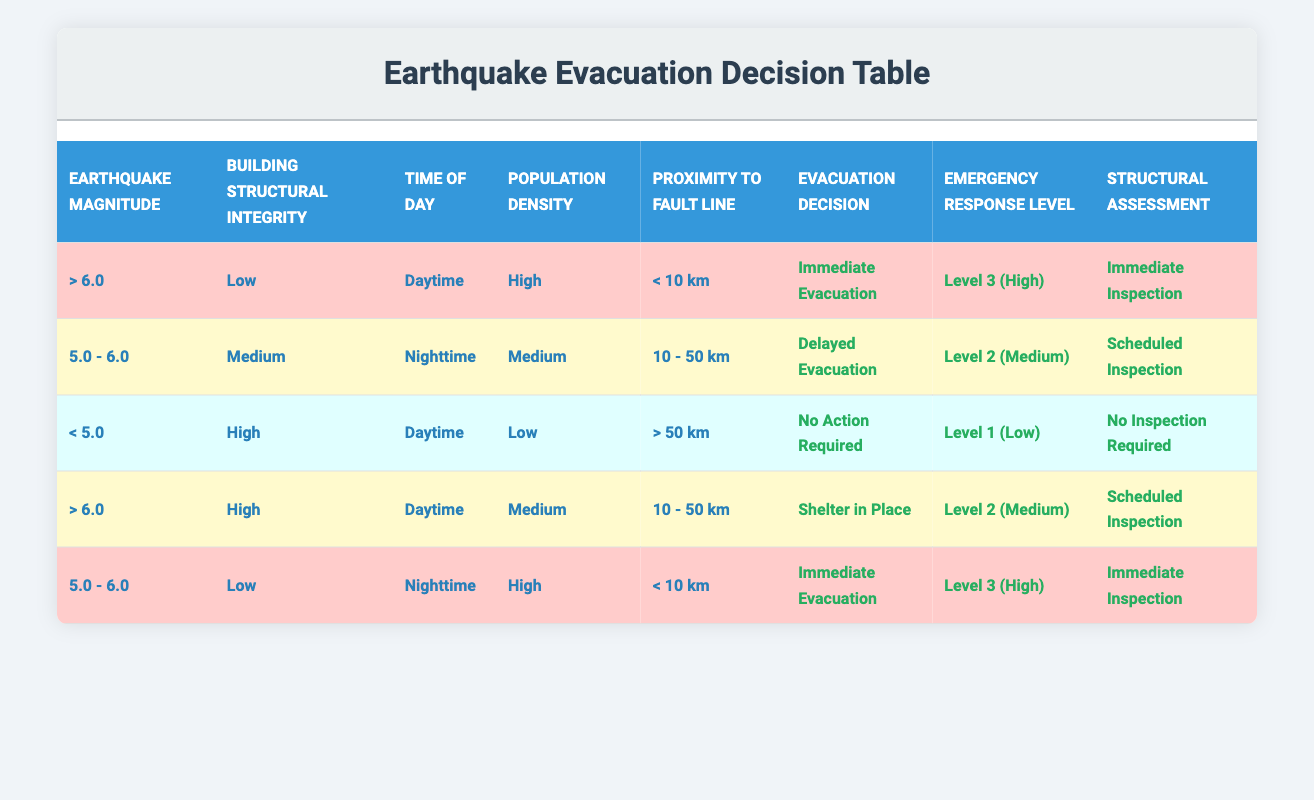What is the evacuation decision for earthquakes greater than 6.0 with low structural integrity during the daytime? In the table, the row corresponding to earthquakes with a magnitude greater than 6.0 and low structural integrity during the daytime indicates that the evacuation decision is "Immediate Evacuation."
Answer: Immediate Evacuation How many conditions lead to "No Action Required"? By examining the table, the only row that states "No Action Required" is for earthquakes less than 5.0, with high structural integrity during the daytime, low population density, and proximity greater than 50 km. Therefore, there is only one condition that leads to this decision.
Answer: 1 Is the emergency response level always high for "Immediate Evacuation?" The table shows that "Immediate Evacuation" corresponds to an emergency response level of "Level 3 (High)" only in certain cases, specifically for earthquakes greater than 6.0 with low structural integrity and for earthquakes of 5.0 to 6.0 with low structural integrity at nighttime. However, it does not apply to all instances of "Immediate Evacuation." Thus, the response level is not always high for this action.
Answer: No What is the difference in emergency response levels between a magnitude of 5.0 - 6.0 at nighttime with medium building integrity and earthquakes greater than 6.0 with high structural integrity during the daytime? The emergency response level for a magnitude of 5.0 - 6.0 at nighttime with medium building integrity is "Level 2 (Medium)," while for earthquakes greater than 6.0 with high structural integrity during the daytime, the level is "Level 2 (Medium)" as well. Since both levels are the same, the difference is zero.
Answer: 0 What evacuation decision and structural assessment will occur for a 5.0 - 6.0 magnitude earthquake during nighttime with low structural integrity and high population density near a fault line less than 10 km? In the table, the conditions specify that for a magnitude of 5.0 - 6.0 during nighttime with low structural integrity and high population density near a fault line less than 10 km, the evacuation decision is "Immediate Evacuation," and the structural assessment is "Immediate Inspection."
Answer: Immediate Evacuation; Immediate Inspection 